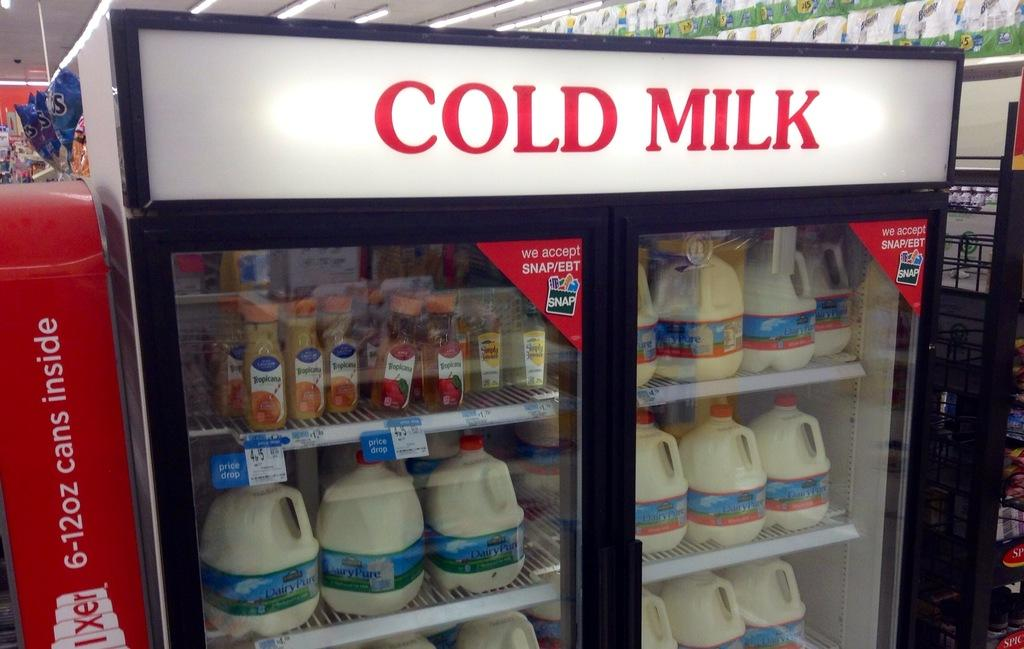<image>
Summarize the visual content of the image. A beverage refrigerator in a store containing Cold Milk 